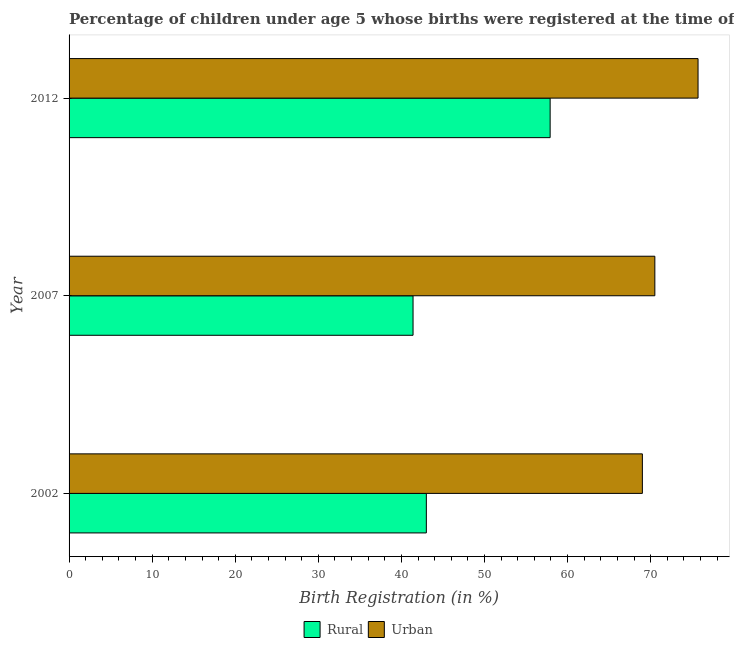How many different coloured bars are there?
Your response must be concise. 2. Are the number of bars per tick equal to the number of legend labels?
Your answer should be compact. Yes. How many bars are there on the 3rd tick from the top?
Offer a terse response. 2. What is the rural birth registration in 2007?
Provide a succinct answer. 41.4. Across all years, what is the maximum rural birth registration?
Offer a very short reply. 57.9. Across all years, what is the minimum rural birth registration?
Offer a very short reply. 41.4. In which year was the urban birth registration maximum?
Make the answer very short. 2012. In which year was the urban birth registration minimum?
Your answer should be compact. 2002. What is the total urban birth registration in the graph?
Keep it short and to the point. 215.2. What is the difference between the rural birth registration in 2002 and that in 2007?
Your answer should be compact. 1.6. What is the difference between the rural birth registration in 2002 and the urban birth registration in 2012?
Your answer should be very brief. -32.7. What is the average urban birth registration per year?
Offer a very short reply. 71.73. In the year 2007, what is the difference between the urban birth registration and rural birth registration?
Provide a short and direct response. 29.1. What is the ratio of the urban birth registration in 2007 to that in 2012?
Keep it short and to the point. 0.93. What is the difference between the highest and the second highest rural birth registration?
Keep it short and to the point. 14.9. Is the sum of the rural birth registration in 2002 and 2012 greater than the maximum urban birth registration across all years?
Give a very brief answer. Yes. What does the 1st bar from the top in 2007 represents?
Ensure brevity in your answer.  Urban. What does the 2nd bar from the bottom in 2002 represents?
Keep it short and to the point. Urban. Are all the bars in the graph horizontal?
Make the answer very short. Yes. What is the difference between two consecutive major ticks on the X-axis?
Offer a terse response. 10. Are the values on the major ticks of X-axis written in scientific E-notation?
Offer a very short reply. No. Where does the legend appear in the graph?
Give a very brief answer. Bottom center. How many legend labels are there?
Provide a succinct answer. 2. What is the title of the graph?
Offer a very short reply. Percentage of children under age 5 whose births were registered at the time of the survey in Indonesia. What is the label or title of the X-axis?
Your answer should be compact. Birth Registration (in %). What is the label or title of the Y-axis?
Give a very brief answer. Year. What is the Birth Registration (in %) in Rural in 2002?
Give a very brief answer. 43. What is the Birth Registration (in %) of Urban in 2002?
Give a very brief answer. 69. What is the Birth Registration (in %) of Rural in 2007?
Ensure brevity in your answer.  41.4. What is the Birth Registration (in %) in Urban in 2007?
Offer a terse response. 70.5. What is the Birth Registration (in %) in Rural in 2012?
Offer a terse response. 57.9. What is the Birth Registration (in %) in Urban in 2012?
Your response must be concise. 75.7. Across all years, what is the maximum Birth Registration (in %) of Rural?
Ensure brevity in your answer.  57.9. Across all years, what is the maximum Birth Registration (in %) of Urban?
Offer a very short reply. 75.7. Across all years, what is the minimum Birth Registration (in %) in Rural?
Provide a short and direct response. 41.4. What is the total Birth Registration (in %) of Rural in the graph?
Make the answer very short. 142.3. What is the total Birth Registration (in %) in Urban in the graph?
Provide a short and direct response. 215.2. What is the difference between the Birth Registration (in %) in Urban in 2002 and that in 2007?
Make the answer very short. -1.5. What is the difference between the Birth Registration (in %) of Rural in 2002 and that in 2012?
Your answer should be very brief. -14.9. What is the difference between the Birth Registration (in %) in Urban in 2002 and that in 2012?
Keep it short and to the point. -6.7. What is the difference between the Birth Registration (in %) in Rural in 2007 and that in 2012?
Offer a very short reply. -16.5. What is the difference between the Birth Registration (in %) of Urban in 2007 and that in 2012?
Provide a succinct answer. -5.2. What is the difference between the Birth Registration (in %) in Rural in 2002 and the Birth Registration (in %) in Urban in 2007?
Your answer should be compact. -27.5. What is the difference between the Birth Registration (in %) of Rural in 2002 and the Birth Registration (in %) of Urban in 2012?
Provide a short and direct response. -32.7. What is the difference between the Birth Registration (in %) in Rural in 2007 and the Birth Registration (in %) in Urban in 2012?
Give a very brief answer. -34.3. What is the average Birth Registration (in %) of Rural per year?
Offer a very short reply. 47.43. What is the average Birth Registration (in %) of Urban per year?
Your response must be concise. 71.73. In the year 2007, what is the difference between the Birth Registration (in %) in Rural and Birth Registration (in %) in Urban?
Your answer should be very brief. -29.1. In the year 2012, what is the difference between the Birth Registration (in %) in Rural and Birth Registration (in %) in Urban?
Your answer should be compact. -17.8. What is the ratio of the Birth Registration (in %) of Rural in 2002 to that in 2007?
Your answer should be compact. 1.04. What is the ratio of the Birth Registration (in %) in Urban in 2002 to that in 2007?
Your response must be concise. 0.98. What is the ratio of the Birth Registration (in %) of Rural in 2002 to that in 2012?
Your response must be concise. 0.74. What is the ratio of the Birth Registration (in %) in Urban in 2002 to that in 2012?
Offer a very short reply. 0.91. What is the ratio of the Birth Registration (in %) in Rural in 2007 to that in 2012?
Your answer should be very brief. 0.71. What is the ratio of the Birth Registration (in %) in Urban in 2007 to that in 2012?
Offer a terse response. 0.93. What is the difference between the highest and the second highest Birth Registration (in %) of Rural?
Provide a short and direct response. 14.9. What is the difference between the highest and the lowest Birth Registration (in %) of Urban?
Offer a terse response. 6.7. 